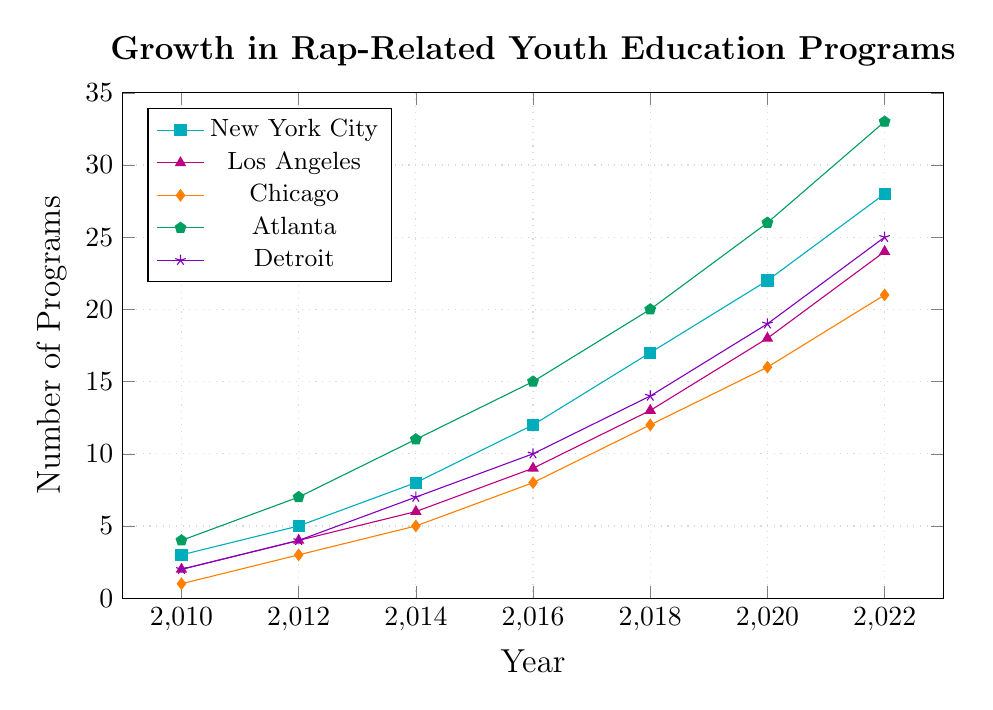Which city had the highest number of rap-related youth education programs in 2022? In 2022, Atlanta had the highest number of programs at 33.
Answer: Atlanta Which city saw the largest increase in the number of rap-related youth education programs from 2010 to 2022? Atlanta had 4 programs in 2010 and 33 in 2022, an increase of 29 programs. The other cities had smaller increases.
Answer: Atlanta How many rap-related youth education programs were there in total across all cities in 2018? Add the number of programs for each city in 2018: 17 (NYC) + 13 (LA) + 12 (Chicago) + 20 (Atlanta) + 14 (Detroit) = 76.
Answer: 76 By how many programs did New York City exceed Chicago in 2016? In 2016, New York City had 12 programs, and Chicago had 8, so NYC exceeded Chicago by 12 - 8 = 4 programs.
Answer: 4 Which two cities had the same number of rap-related youth education programs in 2012? In 2012, both Los Angeles and Detroit had 4 programs each.
Answer: Los Angeles and Detroit What was the average number of programs across all cities in 2020? Add the number of programs for each city in 2020 and divide by 5: (22 + 18 + 16 + 26 + 19) / 5 = 101 / 5 = 20.2.
Answer: 20.2 In what year did Detroit first surpass 10 rap-related youth education programs? In 2016, Detroit had 10 programs, and in 2018, it had 14. Detroit first surpassed 10 programs in 2018.
Answer: 2018 Which city had the lowest number of programs in 2022 and how many did it have? In 2022, Chicago had the lowest number of programs with 21.
Answer: Chicago, 21 Compare the growth pattern of New York City and Los Angeles. Which city had a steeper growth rate between 2010 and 2022? New York City's programs increased from 3 to 28 (25 programs), while Los Angeles' increased from 2 to 24 (22 programs). New York City had a steeper growth rate.
Answer: New York City Between 2014 and 2018, which city saw the largest absolute increase in the number of programs? Atlanta saw an increase from 11 in 2014 to 20 in 2018, an increase of 9 programs, which is the largest increase among the cities.
Answer: Atlanta 